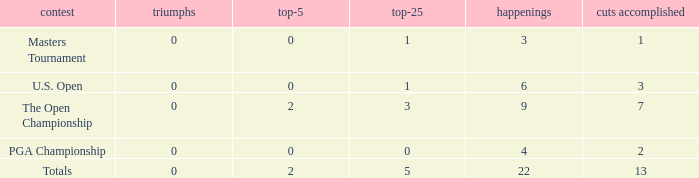What is the fewest wins for Thomas in events he had entered exactly 9 times? 0.0. 